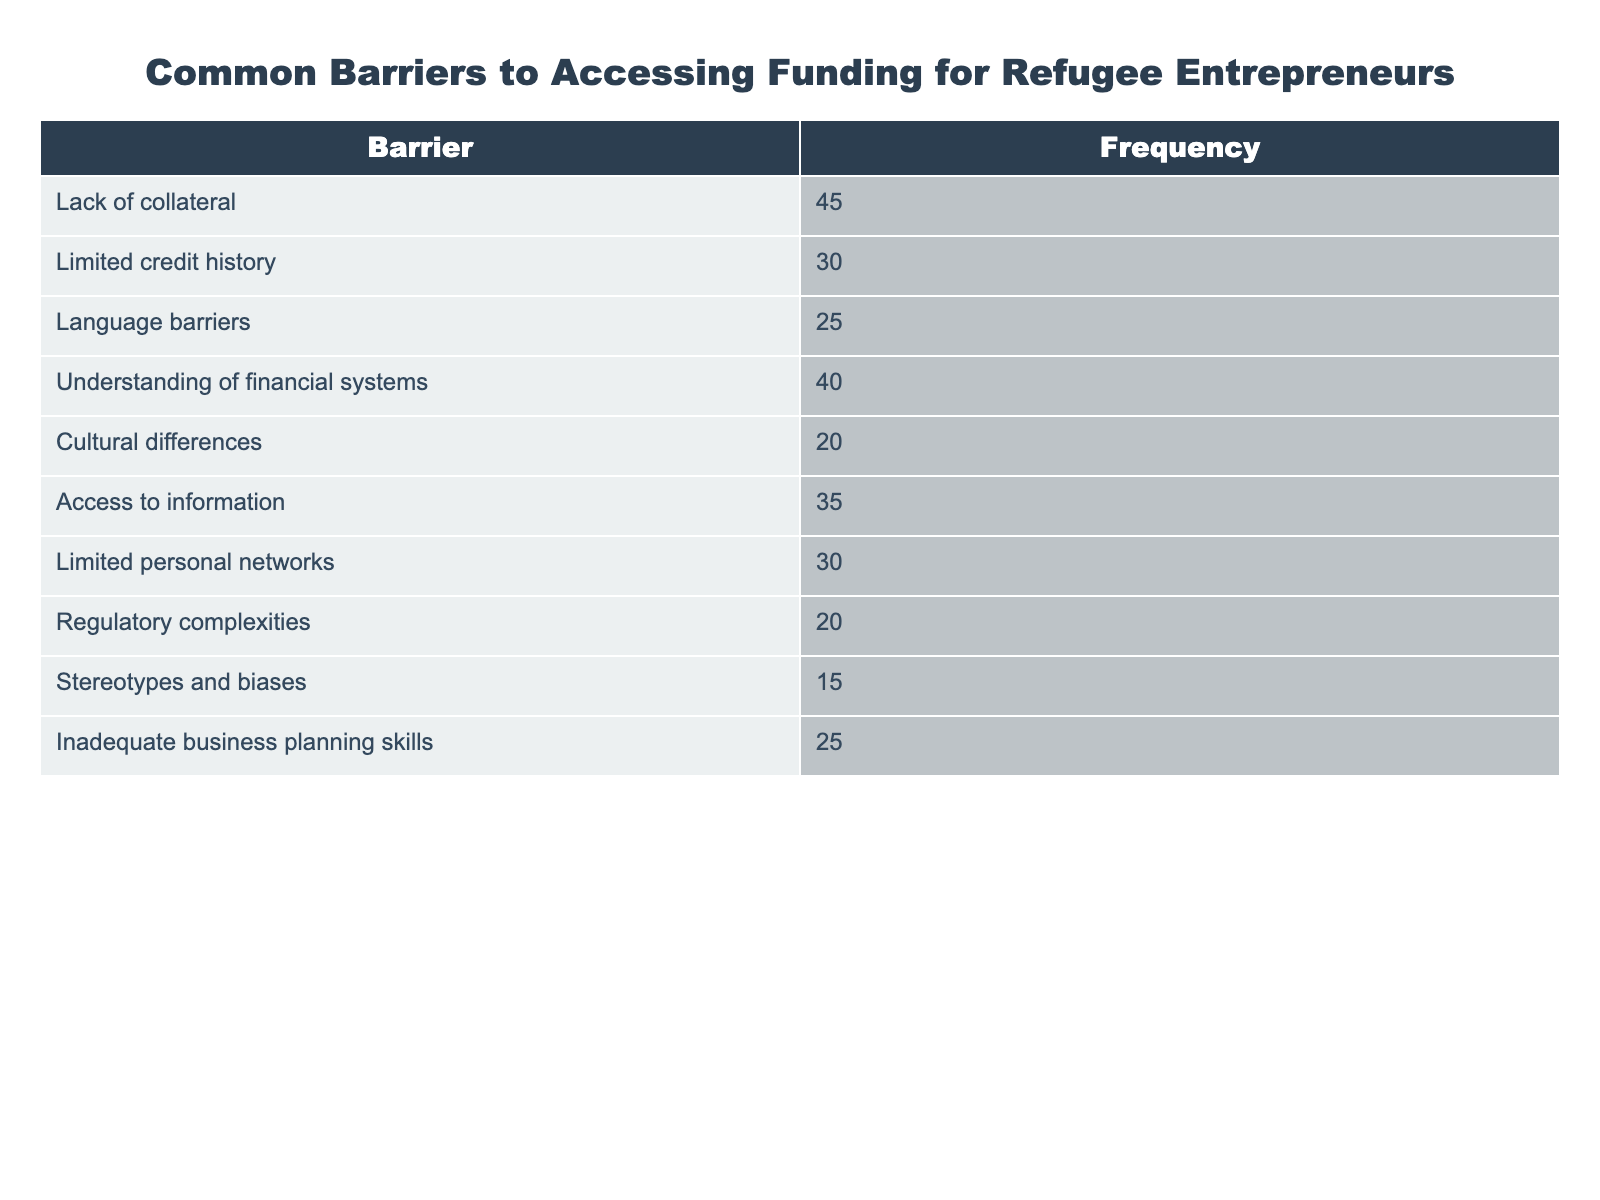What is the frequency of the barrier 'Limited credit history'? The table lists the barriers along with their respective frequencies. By locating 'Limited credit history' in the first column, we can see that its corresponding frequency is 30.
Answer: 30 Which barrier has the highest frequency? By examining the frequencies listed in the second column, we identify 'Lack of collateral' with a frequency of 45, which is greater than all other barriers.
Answer: Lack of collateral How many barriers have a frequency of 25 or higher? We list the barriers with frequencies 25 or higher: 'Lack of collateral' (45), 'Understanding of financial systems' (40), 'Access to information' (35), 'Limited credit history' (30), 'Inadequate business planning skills' (25), 'Language barriers' (25). There are a total of 6 barriers that meet this condition.
Answer: 6 What is the total frequency of barriers related to cultural differences? The barriers directly related to cultural differences are 'Cultural differences' (20) and 'Stereotypes and biases' (15). Adding these frequencies together gives us a total of 20 + 15 = 35.
Answer: 35 Is 'Access to information' more frequent than 'Language barriers'? Comparing the two frequencies: 'Access to information' has a frequency of 35 and 'Language barriers' has a frequency of 25. Since 35 is greater than 25, the statement is true.
Answer: Yes What is the average frequency of the barriers listed in the table? To find the average, we sum all frequencies: 45 + 30 + 25 + 40 + 20 + 35 + 30 + 20 + 15 + 25 = 315. There are 10 barriers, so we divide the total (315) by the number of barriers (10), resulting in an average of 31.5.
Answer: 31.5 What is the difference in frequency between the barrier with the highest and lowest frequency? The highest frequency is for 'Lack of collateral' (45) and the lowest is 'Stereotypes and biases' (15). The difference is 45 - 15 = 30.
Answer: 30 Are there more barriers related to financial knowledge than to personal characteristics? Counting barriers that pertain to financial knowledge: 'Limited credit history' (30), 'Understanding of financial systems' (40), and 'Inadequate business planning skills' (25) gives a total of 3. For personal characteristics: 'Cultural differences' (20), 'Language barriers' (25), and 'Stereotypes and biases' (15) gives us a total of 3 as well. Since both categories have the same number of barriers, the answer is no.
Answer: No 